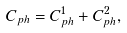<formula> <loc_0><loc_0><loc_500><loc_500>C _ { p h } = C _ { p h } ^ { 1 } + C _ { p h } ^ { 2 } ,</formula> 